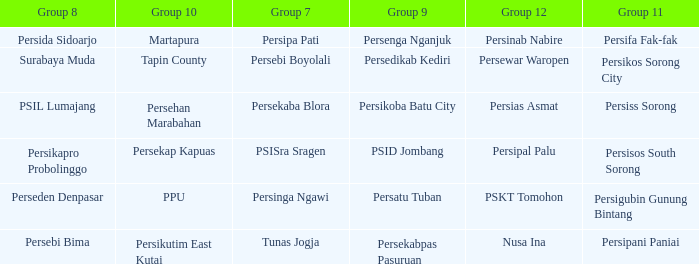Nusa Ina only played once while group 7 played. 1.0. Can you parse all the data within this table? {'header': ['Group 8', 'Group 10', 'Group 7', 'Group 9', 'Group 12', 'Group 11'], 'rows': [['Persida Sidoarjo', 'Martapura', 'Persipa Pati', 'Persenga Nganjuk', 'Persinab Nabire', 'Persifa Fak-fak'], ['Surabaya Muda', 'Tapin County', 'Persebi Boyolali', 'Persedikab Kediri', 'Persewar Waropen', 'Persikos Sorong City'], ['PSIL Lumajang', 'Persehan Marabahan', 'Persekaba Blora', 'Persikoba Batu City', 'Persias Asmat', 'Persiss Sorong'], ['Persikapro Probolinggo', 'Persekap Kapuas', 'PSISra Sragen', 'PSID Jombang', 'Persipal Palu', 'Persisos South Sorong'], ['Perseden Denpasar', 'PPU', 'Persinga Ngawi', 'Persatu Tuban', 'PSKT Tomohon', 'Persigubin Gunung Bintang'], ['Persebi Bima', 'Persikutim East Kutai', 'Tunas Jogja', 'Persekabpas Pasuruan', 'Nusa Ina', 'Persipani Paniai']]} 